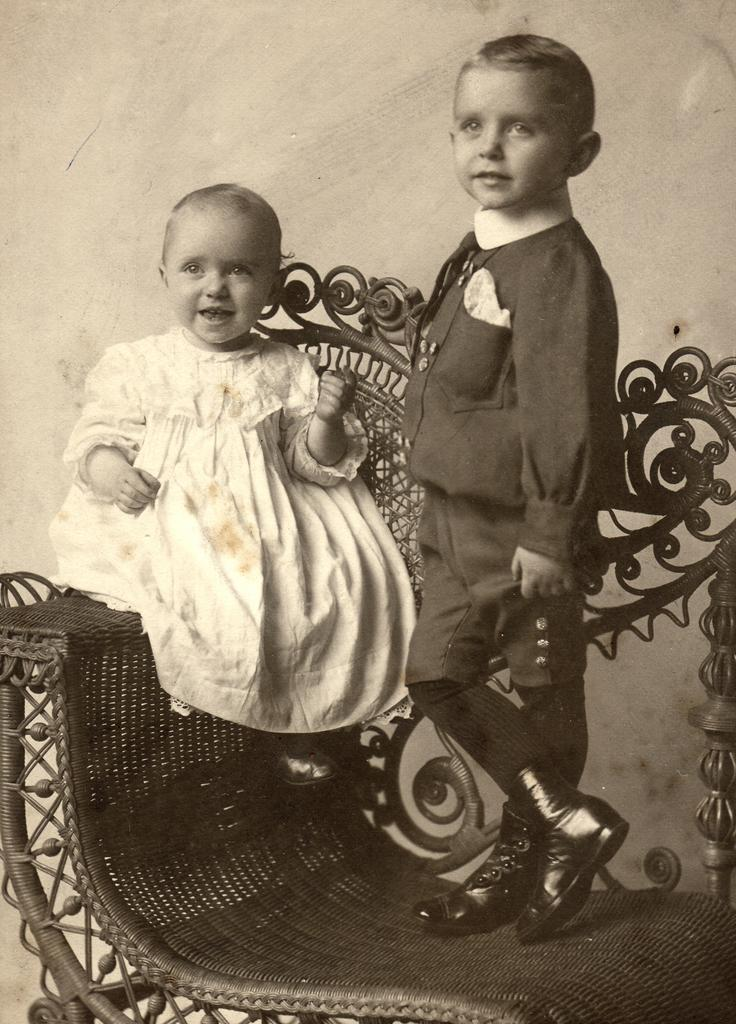What is the main subject of the image? The main subject of the image is an old photograph. What can be seen in the photograph? A boy is standing, and a girl is sitting on a chair in the photograph. Can you describe the chair in the photograph? The chair is designed, which means it has a unique or decorative appearance. What is behind the chair in the photograph? There is a wall behind the chair in the photograph. How many seeds are visible on the boy's finger in the image? There are no seeds or fingers visible in the image; it features an old photograph of a boy and a girl. 